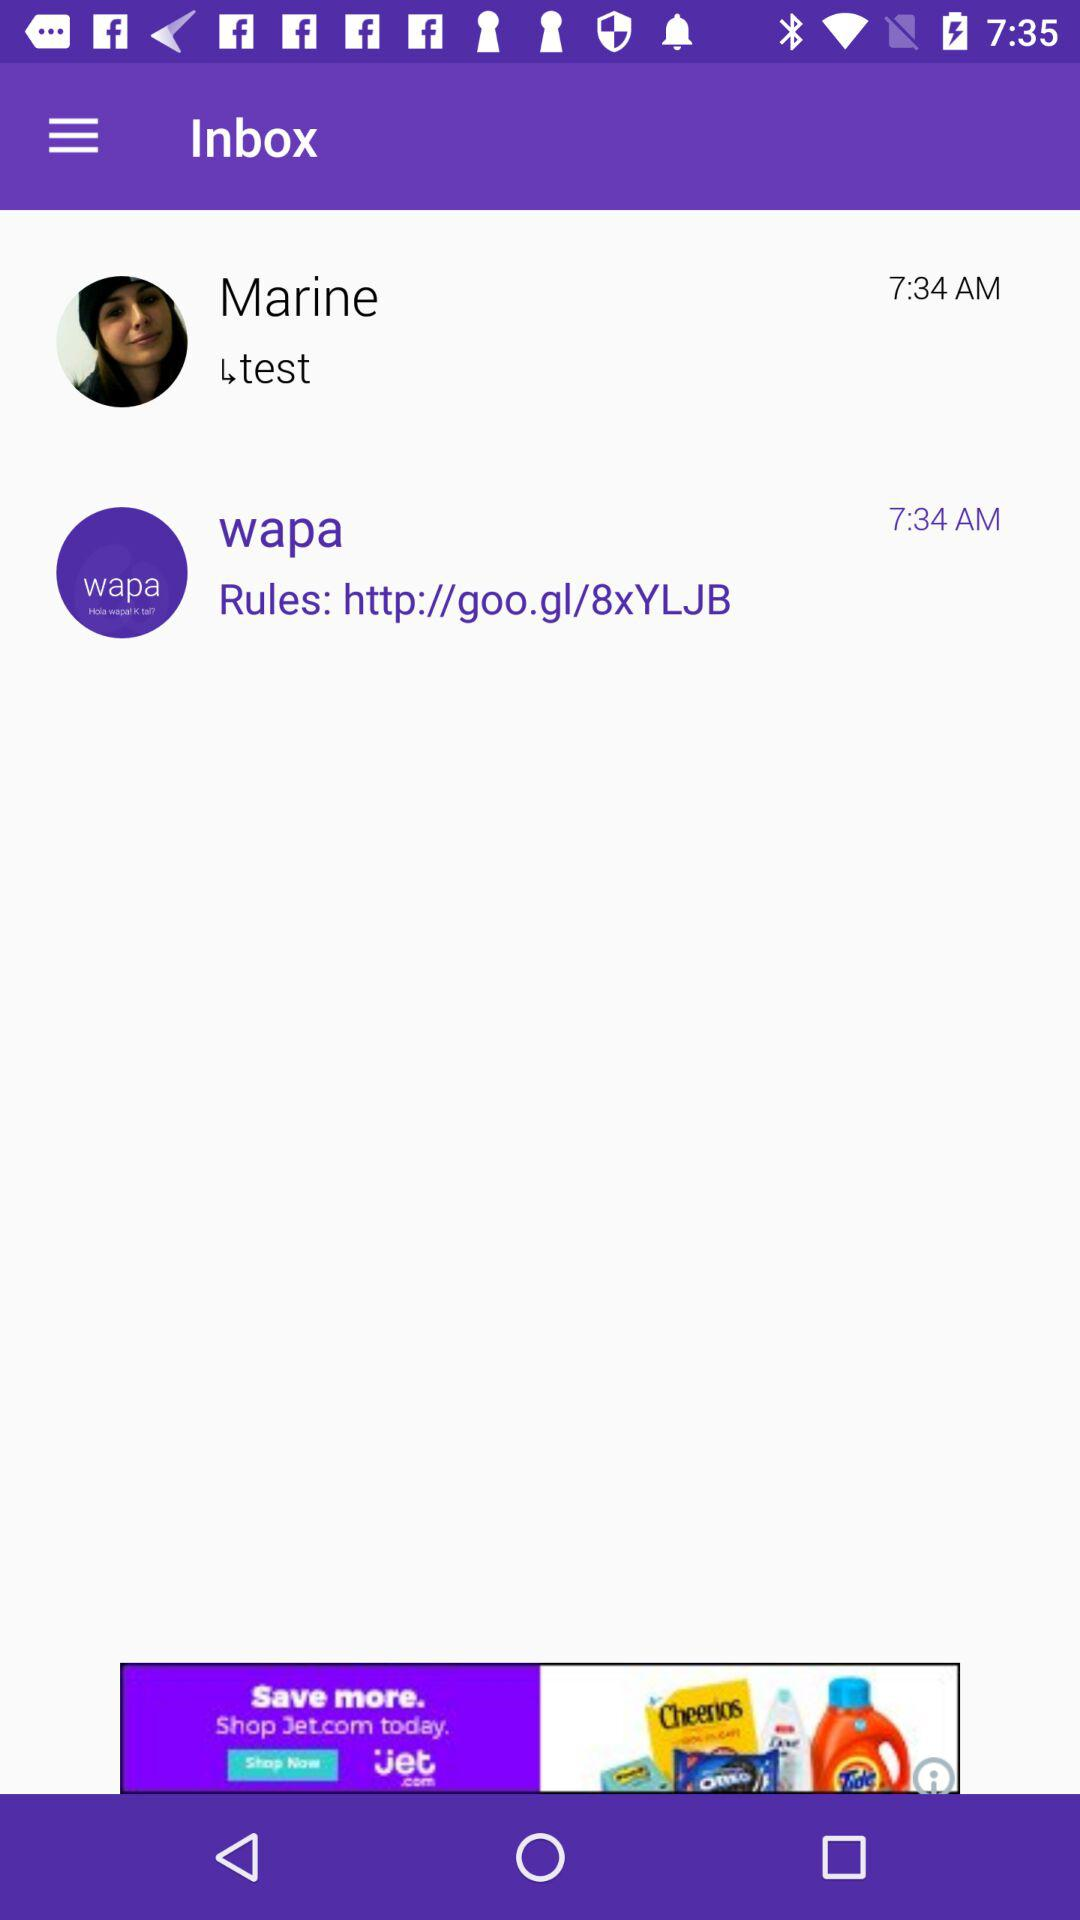When did "wapa" send the last message? The last message by "wapa" was sent at 7:34 AM. 